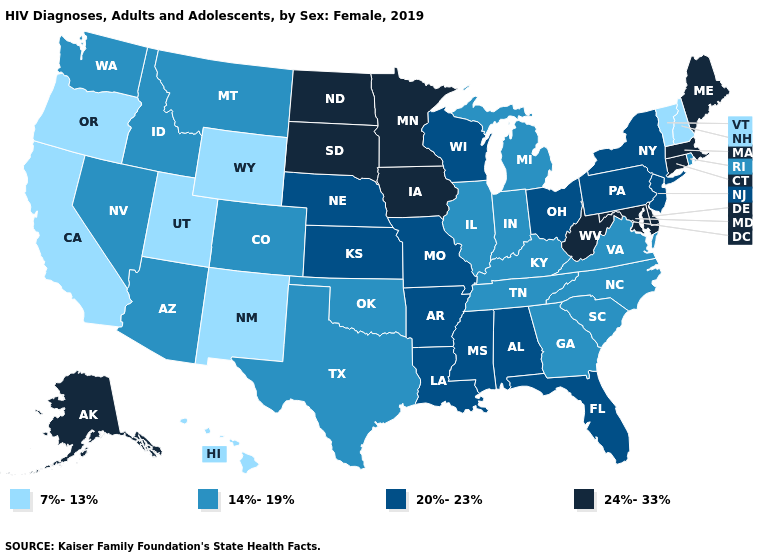Does Indiana have the highest value in the USA?
Answer briefly. No. What is the lowest value in the USA?
Answer briefly. 7%-13%. Name the states that have a value in the range 14%-19%?
Quick response, please. Arizona, Colorado, Georgia, Idaho, Illinois, Indiana, Kentucky, Michigan, Montana, Nevada, North Carolina, Oklahoma, Rhode Island, South Carolina, Tennessee, Texas, Virginia, Washington. What is the lowest value in the MidWest?
Quick response, please. 14%-19%. Name the states that have a value in the range 14%-19%?
Answer briefly. Arizona, Colorado, Georgia, Idaho, Illinois, Indiana, Kentucky, Michigan, Montana, Nevada, North Carolina, Oklahoma, Rhode Island, South Carolina, Tennessee, Texas, Virginia, Washington. What is the value of Louisiana?
Short answer required. 20%-23%. Name the states that have a value in the range 20%-23%?
Short answer required. Alabama, Arkansas, Florida, Kansas, Louisiana, Mississippi, Missouri, Nebraska, New Jersey, New York, Ohio, Pennsylvania, Wisconsin. Is the legend a continuous bar?
Quick response, please. No. Name the states that have a value in the range 7%-13%?
Give a very brief answer. California, Hawaii, New Hampshire, New Mexico, Oregon, Utah, Vermont, Wyoming. Is the legend a continuous bar?
Keep it brief. No. Among the states that border Missouri , which have the lowest value?
Concise answer only. Illinois, Kentucky, Oklahoma, Tennessee. What is the value of Massachusetts?
Be succinct. 24%-33%. Name the states that have a value in the range 20%-23%?
Write a very short answer. Alabama, Arkansas, Florida, Kansas, Louisiana, Mississippi, Missouri, Nebraska, New Jersey, New York, Ohio, Pennsylvania, Wisconsin. What is the value of Iowa?
Quick response, please. 24%-33%. How many symbols are there in the legend?
Quick response, please. 4. 